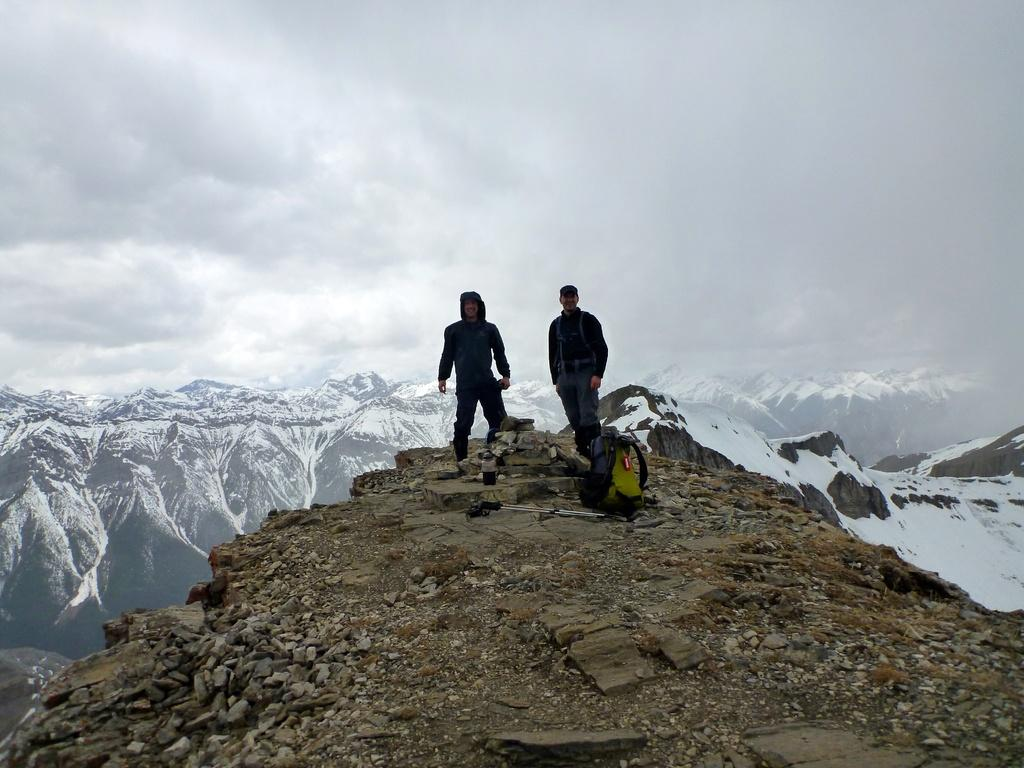How many men are in the image? There are two men standing on the ground in the image. What object can be seen in the image? There is a bag in the image. What type of natural feature is present in the image? There are mountains in the image. What is the weather like in the image? There is snow in the image, and clouds are present in the sky, suggesting a cold and possibly snowy or overcast day. What type of pain is the man experiencing in the image? There is no indication of pain or discomfort in the image; both men appear to be standing comfortably. How many stitches are visible on the man's clothing in the image? There are no visible stitches on the men's clothing in the image. 